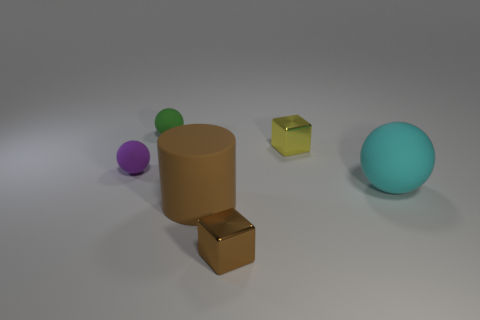Subtract all green rubber balls. How many balls are left? 2 Add 2 purple objects. How many objects exist? 8 Subtract all cyan spheres. How many spheres are left? 2 Subtract all cylinders. How many objects are left? 5 Subtract 1 blocks. How many blocks are left? 1 Subtract all cyan balls. Subtract all green cylinders. How many balls are left? 2 Subtract all green cylinders. How many brown cubes are left? 1 Subtract all metallic cylinders. Subtract all big brown cylinders. How many objects are left? 5 Add 5 small rubber things. How many small rubber things are left? 7 Add 6 large brown things. How many large brown things exist? 7 